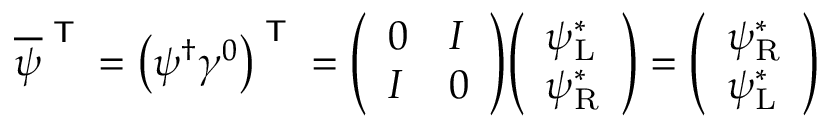<formula> <loc_0><loc_0><loc_500><loc_500>{ \overline { \psi } } ^ { T } = \left ( \psi ^ { \dagger } \gamma ^ { 0 } \right ) ^ { T } = { \left ( \begin{array} { l l } { 0 } & { I } \\ { I } & { 0 } \end{array} \right ) } { \left ( \begin{array} { l } { \psi _ { L } ^ { * } } \\ { \psi _ { R } ^ { * } } \end{array} \right ) } = { \left ( \begin{array} { l } { \psi _ { R } ^ { * } } \\ { \psi _ { L } ^ { * } } \end{array} \right ) }</formula> 